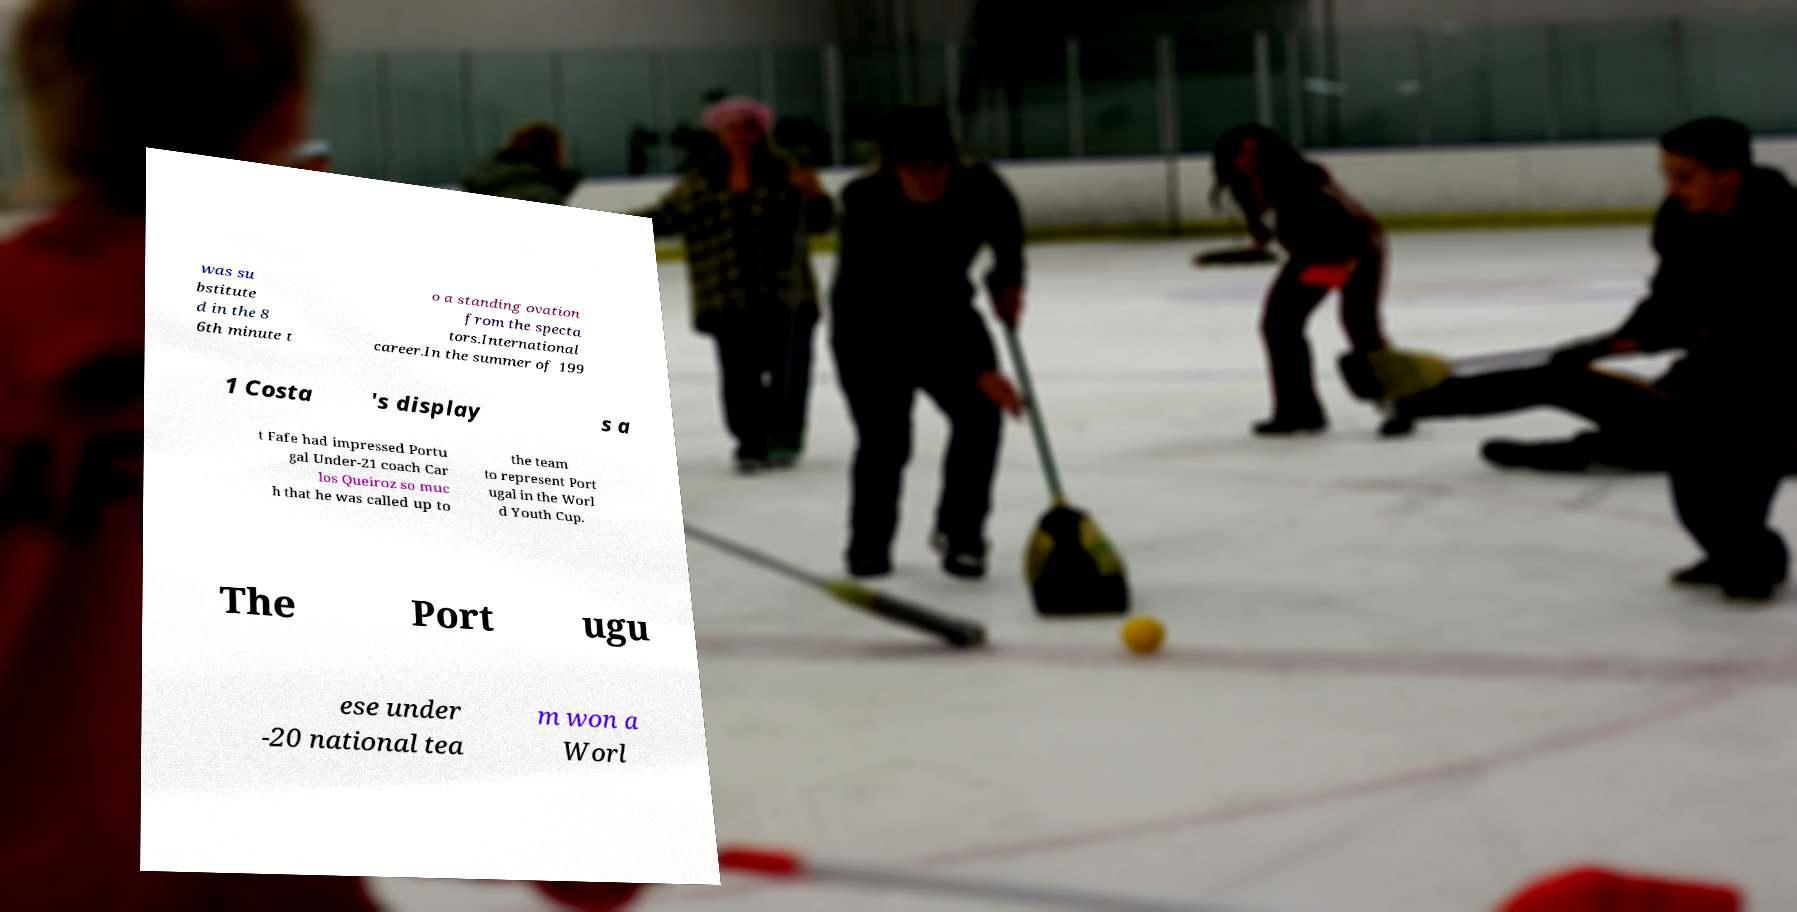Please identify and transcribe the text found in this image. was su bstitute d in the 8 6th minute t o a standing ovation from the specta tors.International career.In the summer of 199 1 Costa 's display s a t Fafe had impressed Portu gal Under-21 coach Car los Queiroz so muc h that he was called up to the team to represent Port ugal in the Worl d Youth Cup. The Port ugu ese under -20 national tea m won a Worl 